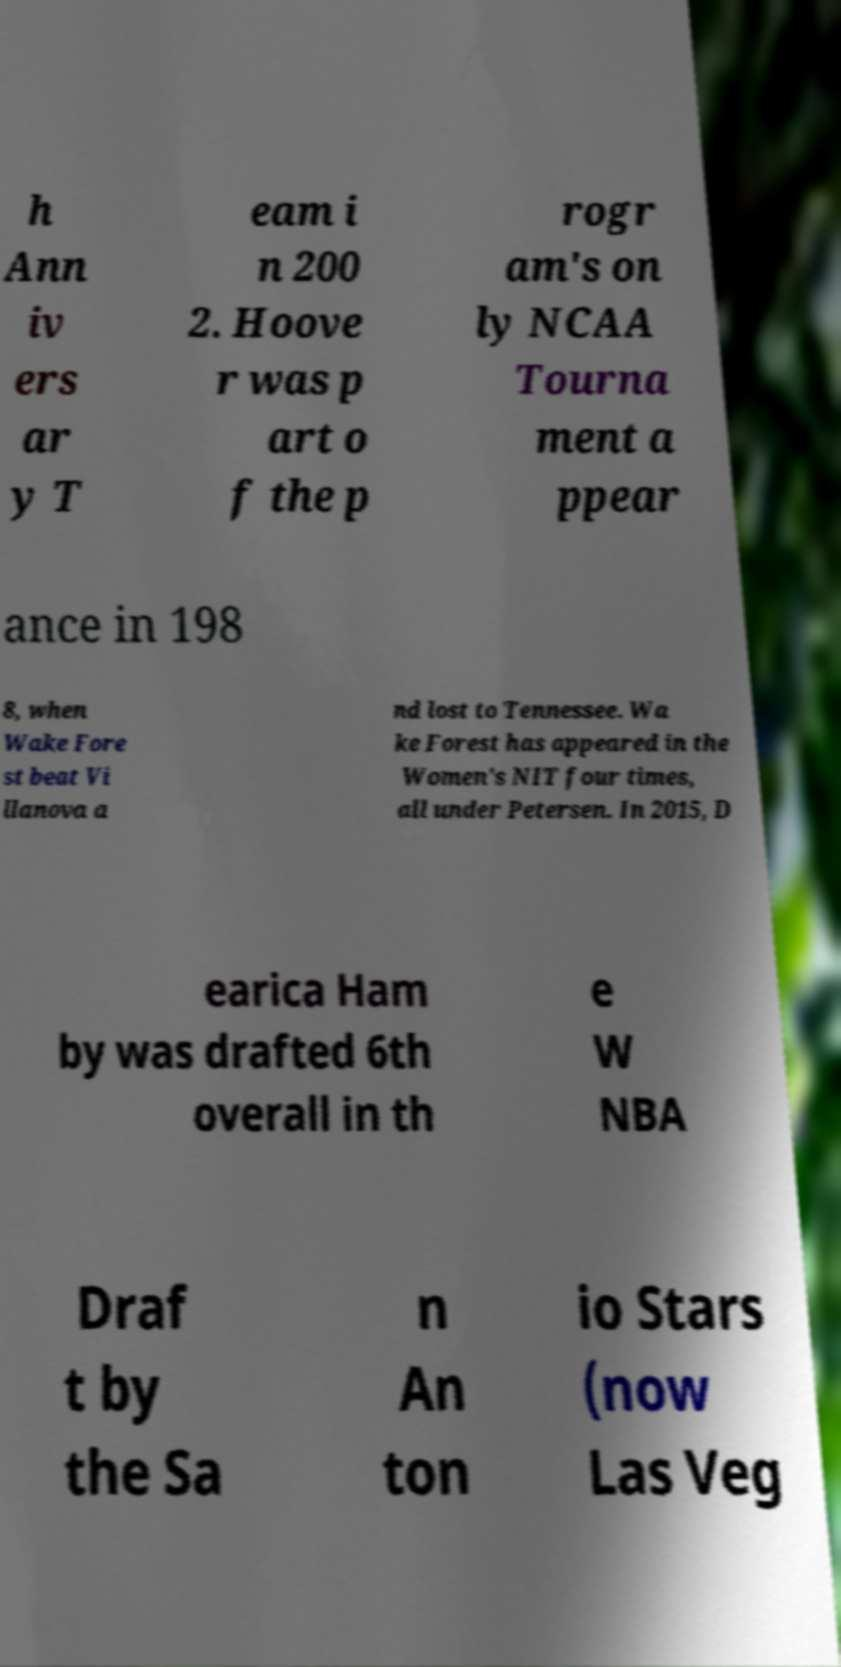There's text embedded in this image that I need extracted. Can you transcribe it verbatim? h Ann iv ers ar y T eam i n 200 2. Hoove r was p art o f the p rogr am's on ly NCAA Tourna ment a ppear ance in 198 8, when Wake Fore st beat Vi llanova a nd lost to Tennessee. Wa ke Forest has appeared in the Women's NIT four times, all under Petersen. In 2015, D earica Ham by was drafted 6th overall in th e W NBA Draf t by the Sa n An ton io Stars (now Las Veg 